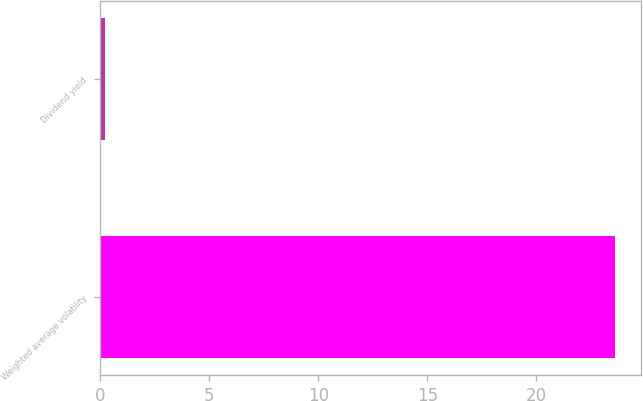Convert chart. <chart><loc_0><loc_0><loc_500><loc_500><bar_chart><fcel>Weighted average volatility<fcel>Dividend yield<nl><fcel>23.6<fcel>0.2<nl></chart> 